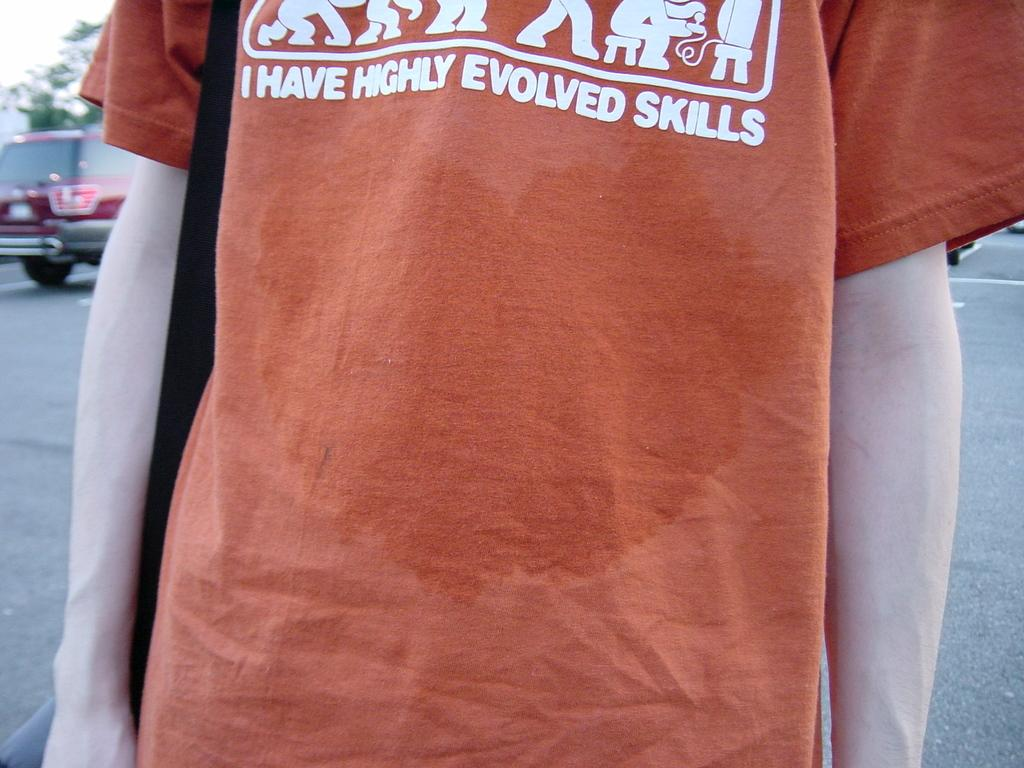<image>
Share a concise interpretation of the image provided. A wet orange shirt saying the person has highly evolved skills 